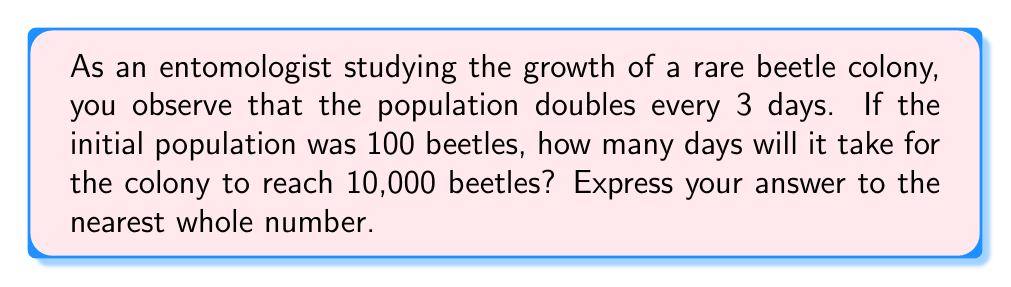Could you help me with this problem? Let's approach this step-by-step using logarithms:

1) Let $N$ be the number of beetles after $t$ days. We can express this as:

   $N = 100 \cdot 2^{\frac{t}{3}}$

2) We want to find $t$ when $N = 10,000$. So, we can set up the equation:

   $10,000 = 100 \cdot 2^{\frac{t}{3}}$

3) Divide both sides by 100:

   $100 = 2^{\frac{t}{3}}$

4) Now, we can take the logarithm (base 2) of both sides:

   $\log_2(100) = \log_2(2^{\frac{t}{3}})$

5) Using the logarithm property $\log_a(a^x) = x$, we get:

   $\log_2(100) = \frac{t}{3}$

6) Multiply both sides by 3:

   $3\log_2(100) = t$

7) We can calculate $\log_2(100)$ using the change of base formula:

   $\log_2(100) = \frac{\ln(100)}{\ln(2)} \approx 6.6439$

8) Therefore:

   $t = 3 \cdot 6.6439 \approx 19.9317$

9) Rounding to the nearest whole number:

   $t \approx 20$
Answer: 20 days 